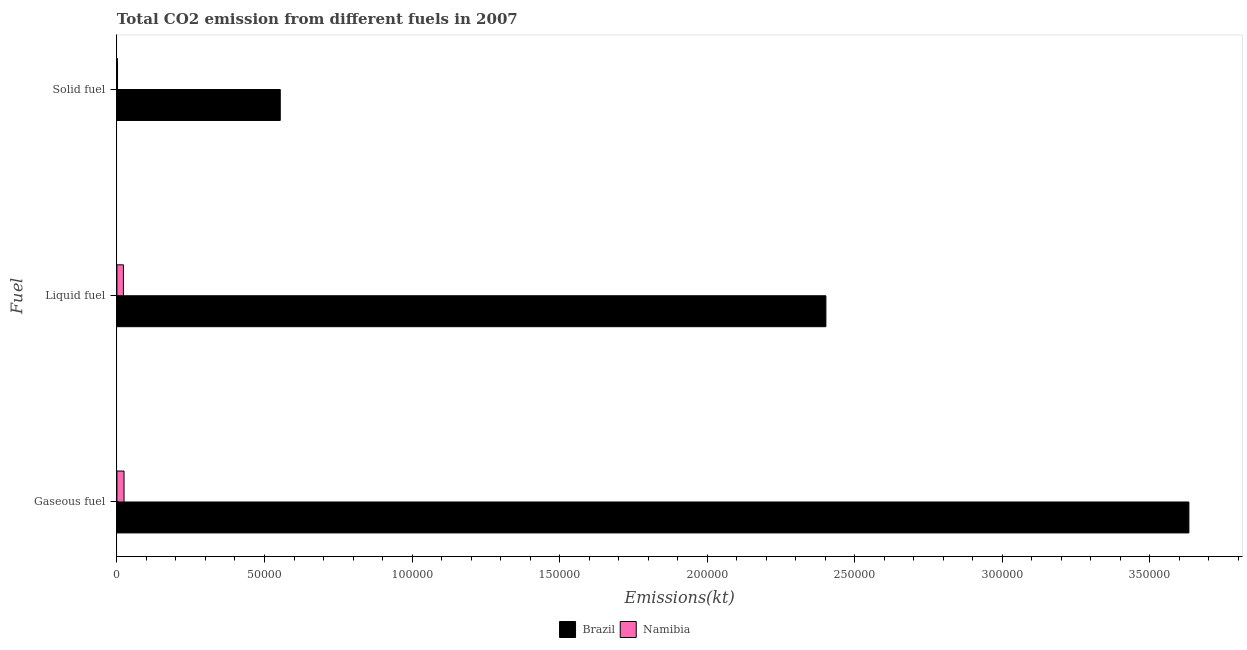Are the number of bars per tick equal to the number of legend labels?
Provide a short and direct response. Yes. Are the number of bars on each tick of the Y-axis equal?
Provide a succinct answer. Yes. How many bars are there on the 2nd tick from the top?
Your response must be concise. 2. How many bars are there on the 3rd tick from the bottom?
Give a very brief answer. 2. What is the label of the 2nd group of bars from the top?
Provide a short and direct response. Liquid fuel. What is the amount of co2 emissions from gaseous fuel in Brazil?
Your answer should be compact. 3.63e+05. Across all countries, what is the maximum amount of co2 emissions from gaseous fuel?
Offer a terse response. 3.63e+05. Across all countries, what is the minimum amount of co2 emissions from solid fuel?
Give a very brief answer. 205.35. In which country was the amount of co2 emissions from liquid fuel maximum?
Your response must be concise. Brazil. In which country was the amount of co2 emissions from gaseous fuel minimum?
Ensure brevity in your answer.  Namibia. What is the total amount of co2 emissions from liquid fuel in the graph?
Your response must be concise. 2.42e+05. What is the difference between the amount of co2 emissions from solid fuel in Brazil and that in Namibia?
Offer a terse response. 5.51e+04. What is the difference between the amount of co2 emissions from solid fuel in Brazil and the amount of co2 emissions from gaseous fuel in Namibia?
Provide a succinct answer. 5.29e+04. What is the average amount of co2 emissions from solid fuel per country?
Your answer should be very brief. 2.78e+04. What is the difference between the amount of co2 emissions from gaseous fuel and amount of co2 emissions from liquid fuel in Namibia?
Your answer should be very brief. 205.35. In how many countries, is the amount of co2 emissions from liquid fuel greater than 230000 kt?
Ensure brevity in your answer.  1. What is the ratio of the amount of co2 emissions from solid fuel in Namibia to that in Brazil?
Ensure brevity in your answer.  0. Is the amount of co2 emissions from gaseous fuel in Brazil less than that in Namibia?
Provide a succinct answer. No. What is the difference between the highest and the second highest amount of co2 emissions from liquid fuel?
Offer a very short reply. 2.38e+05. What is the difference between the highest and the lowest amount of co2 emissions from gaseous fuel?
Offer a very short reply. 3.61e+05. Is the sum of the amount of co2 emissions from solid fuel in Brazil and Namibia greater than the maximum amount of co2 emissions from gaseous fuel across all countries?
Give a very brief answer. No. What does the 1st bar from the top in Solid fuel represents?
Your answer should be compact. Namibia. What does the 1st bar from the bottom in Liquid fuel represents?
Provide a short and direct response. Brazil. Is it the case that in every country, the sum of the amount of co2 emissions from gaseous fuel and amount of co2 emissions from liquid fuel is greater than the amount of co2 emissions from solid fuel?
Offer a terse response. Yes. How many bars are there?
Make the answer very short. 6. Are the values on the major ticks of X-axis written in scientific E-notation?
Provide a succinct answer. No. Does the graph contain grids?
Your answer should be compact. No. What is the title of the graph?
Give a very brief answer. Total CO2 emission from different fuels in 2007. Does "Greenland" appear as one of the legend labels in the graph?
Your answer should be very brief. No. What is the label or title of the X-axis?
Offer a very short reply. Emissions(kt). What is the label or title of the Y-axis?
Ensure brevity in your answer.  Fuel. What is the Emissions(kt) of Brazil in Gaseous fuel?
Keep it short and to the point. 3.63e+05. What is the Emissions(kt) of Namibia in Gaseous fuel?
Your answer should be compact. 2409.22. What is the Emissions(kt) in Brazil in Liquid fuel?
Your response must be concise. 2.40e+05. What is the Emissions(kt) in Namibia in Liquid fuel?
Give a very brief answer. 2203.87. What is the Emissions(kt) in Brazil in Solid fuel?
Your answer should be compact. 5.53e+04. What is the Emissions(kt) of Namibia in Solid fuel?
Provide a short and direct response. 205.35. Across all Fuel, what is the maximum Emissions(kt) in Brazil?
Offer a terse response. 3.63e+05. Across all Fuel, what is the maximum Emissions(kt) in Namibia?
Your response must be concise. 2409.22. Across all Fuel, what is the minimum Emissions(kt) in Brazil?
Give a very brief answer. 5.53e+04. Across all Fuel, what is the minimum Emissions(kt) of Namibia?
Your answer should be very brief. 205.35. What is the total Emissions(kt) of Brazil in the graph?
Give a very brief answer. 6.59e+05. What is the total Emissions(kt) of Namibia in the graph?
Your response must be concise. 4818.44. What is the difference between the Emissions(kt) in Brazil in Gaseous fuel and that in Liquid fuel?
Provide a succinct answer. 1.23e+05. What is the difference between the Emissions(kt) in Namibia in Gaseous fuel and that in Liquid fuel?
Keep it short and to the point. 205.35. What is the difference between the Emissions(kt) in Brazil in Gaseous fuel and that in Solid fuel?
Make the answer very short. 3.08e+05. What is the difference between the Emissions(kt) of Namibia in Gaseous fuel and that in Solid fuel?
Provide a succinct answer. 2203.87. What is the difference between the Emissions(kt) in Brazil in Liquid fuel and that in Solid fuel?
Ensure brevity in your answer.  1.85e+05. What is the difference between the Emissions(kt) in Namibia in Liquid fuel and that in Solid fuel?
Make the answer very short. 1998.52. What is the difference between the Emissions(kt) in Brazil in Gaseous fuel and the Emissions(kt) in Namibia in Liquid fuel?
Your answer should be compact. 3.61e+05. What is the difference between the Emissions(kt) in Brazil in Gaseous fuel and the Emissions(kt) in Namibia in Solid fuel?
Offer a very short reply. 3.63e+05. What is the difference between the Emissions(kt) of Brazil in Liquid fuel and the Emissions(kt) of Namibia in Solid fuel?
Ensure brevity in your answer.  2.40e+05. What is the average Emissions(kt) of Brazil per Fuel?
Give a very brief answer. 2.20e+05. What is the average Emissions(kt) of Namibia per Fuel?
Make the answer very short. 1606.15. What is the difference between the Emissions(kt) in Brazil and Emissions(kt) in Namibia in Gaseous fuel?
Provide a succinct answer. 3.61e+05. What is the difference between the Emissions(kt) of Brazil and Emissions(kt) of Namibia in Liquid fuel?
Your answer should be compact. 2.38e+05. What is the difference between the Emissions(kt) in Brazil and Emissions(kt) in Namibia in Solid fuel?
Make the answer very short. 5.51e+04. What is the ratio of the Emissions(kt) in Brazil in Gaseous fuel to that in Liquid fuel?
Provide a succinct answer. 1.51. What is the ratio of the Emissions(kt) in Namibia in Gaseous fuel to that in Liquid fuel?
Your answer should be very brief. 1.09. What is the ratio of the Emissions(kt) of Brazil in Gaseous fuel to that in Solid fuel?
Provide a short and direct response. 6.56. What is the ratio of the Emissions(kt) of Namibia in Gaseous fuel to that in Solid fuel?
Make the answer very short. 11.73. What is the ratio of the Emissions(kt) in Brazil in Liquid fuel to that in Solid fuel?
Offer a terse response. 4.34. What is the ratio of the Emissions(kt) of Namibia in Liquid fuel to that in Solid fuel?
Provide a short and direct response. 10.73. What is the difference between the highest and the second highest Emissions(kt) in Brazil?
Give a very brief answer. 1.23e+05. What is the difference between the highest and the second highest Emissions(kt) of Namibia?
Offer a very short reply. 205.35. What is the difference between the highest and the lowest Emissions(kt) of Brazil?
Your answer should be very brief. 3.08e+05. What is the difference between the highest and the lowest Emissions(kt) in Namibia?
Your answer should be very brief. 2203.87. 